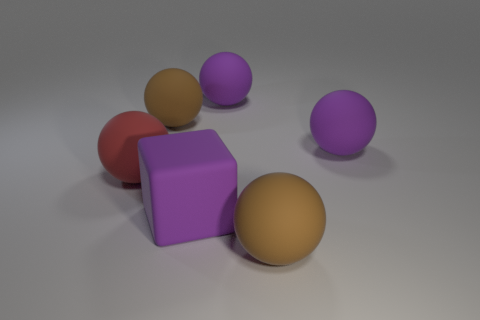Subtract all red spheres. How many spheres are left? 4 Subtract all big red matte balls. How many balls are left? 4 Subtract all gray balls. Subtract all blue blocks. How many balls are left? 5 Add 2 brown balls. How many objects exist? 8 Subtract all blocks. How many objects are left? 5 Subtract all purple blocks. Subtract all purple matte balls. How many objects are left? 3 Add 6 purple rubber spheres. How many purple rubber spheres are left? 8 Add 2 rubber cubes. How many rubber cubes exist? 3 Subtract 0 blue blocks. How many objects are left? 6 